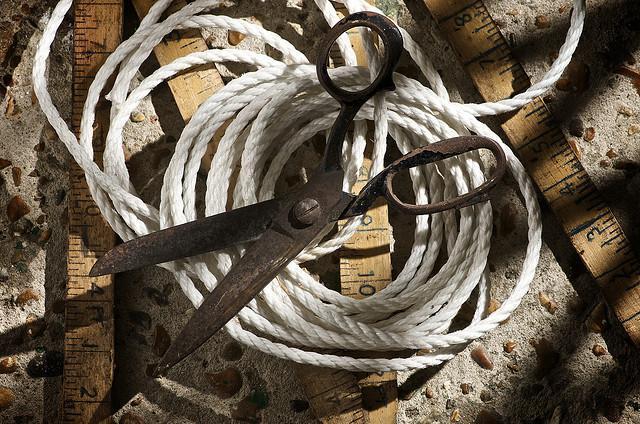How many people are standing up?
Give a very brief answer. 0. 